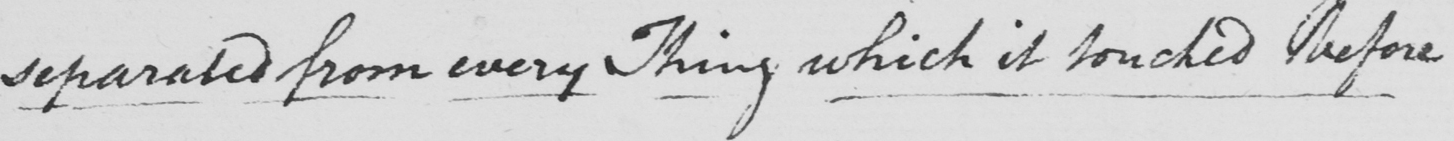What is written in this line of handwriting? separated from every Thing which it touched before 